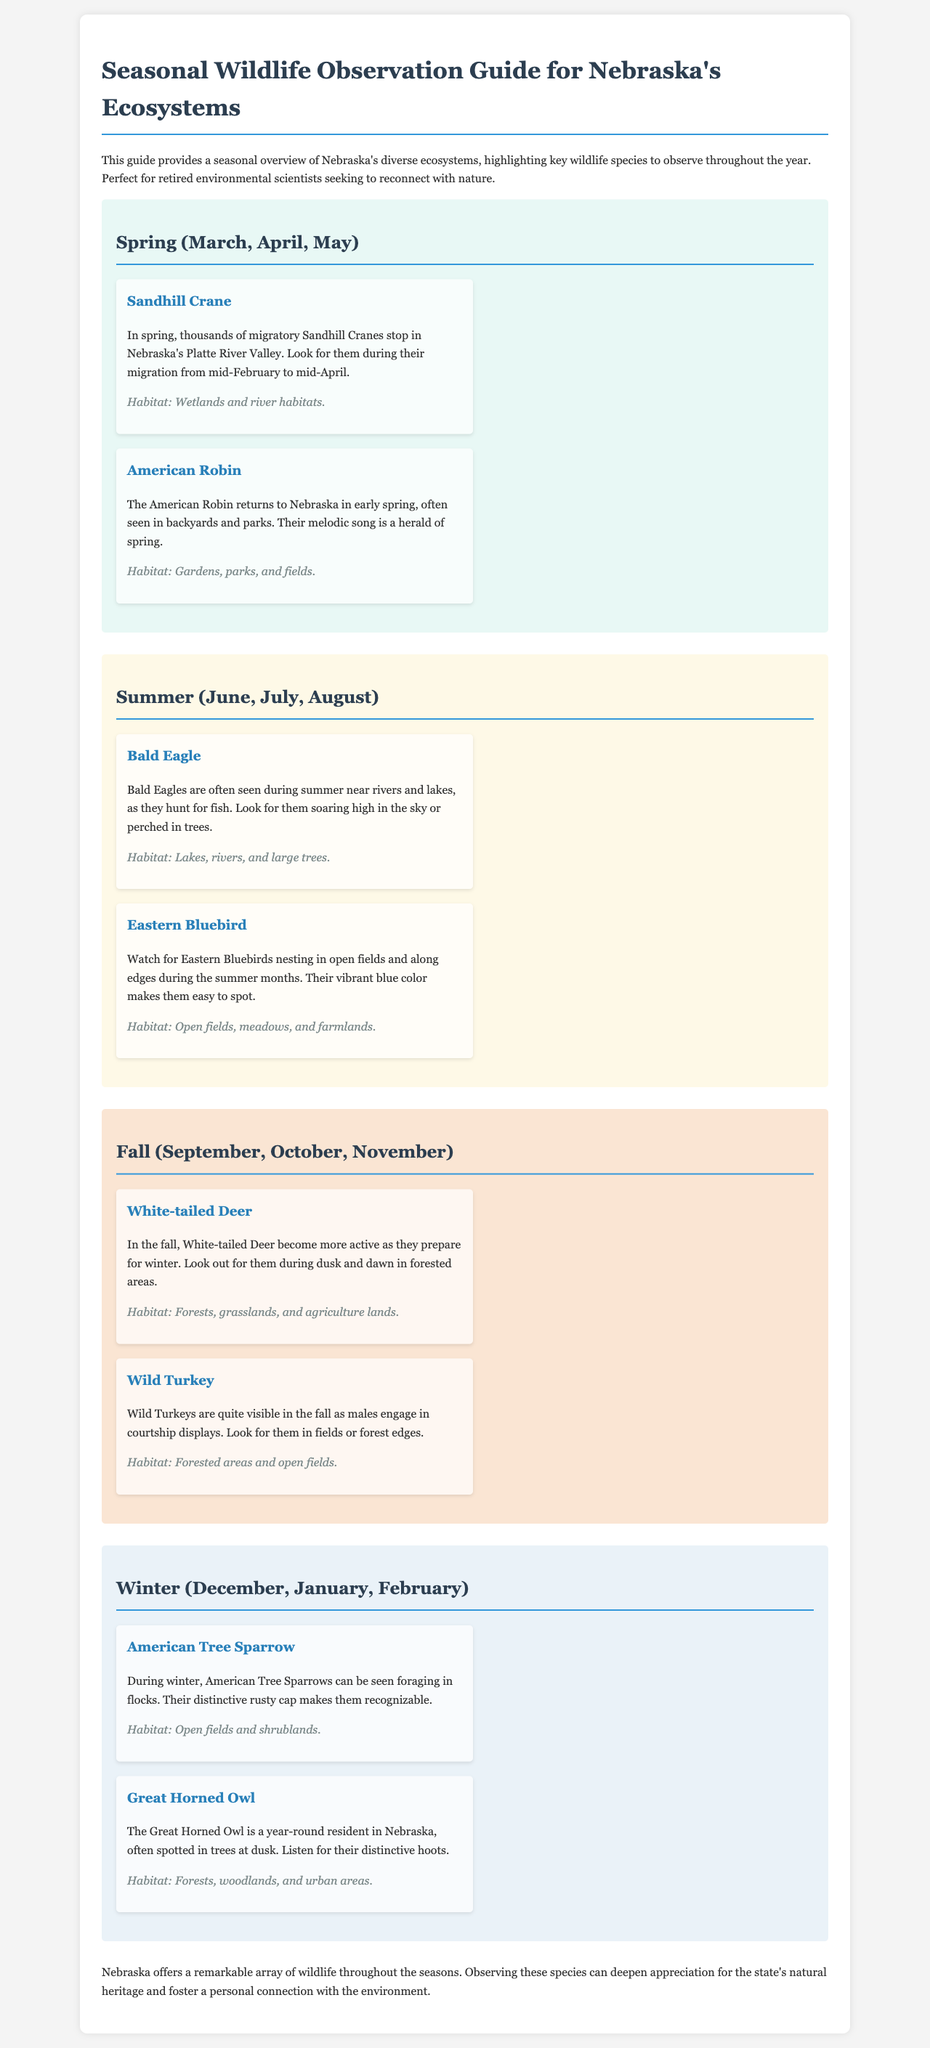What is the primary purpose of the guide? The guide provides a seasonal overview of Nebraska's diverse ecosystems, highlighting key wildlife species to observe throughout the year.
Answer: Seasonal overview of Nebraska's ecosystems During which months can Sandhill Cranes be observed? The Sandhill Cranes migrate from mid-February to mid-April, making them observable in early spring.
Answer: Mid-February to mid-April What habitat do Bald Eagles prefer? Bald Eagles are typically seen near water sources as they hunt for fish, requiring specific habitats.
Answer: Lakes, rivers, and large trees Which species is noted for its vibrant blue color? The Eastern Bluebird is known for its distinctive blue plumage making it easy to spot during the summer months.
Answer: Eastern Bluebird What activity characterizes White-tailed Deer in the fall? White-tailed Deer become more active as they prepare for winter, which relates to their behavior in the fall season.
Answer: More active Which bird is noted for its distinctive hoots? The Great Horned Owl's communication consists of distinctive sounds, which is prominent in the winter.
Answer: Great Horned Owl 